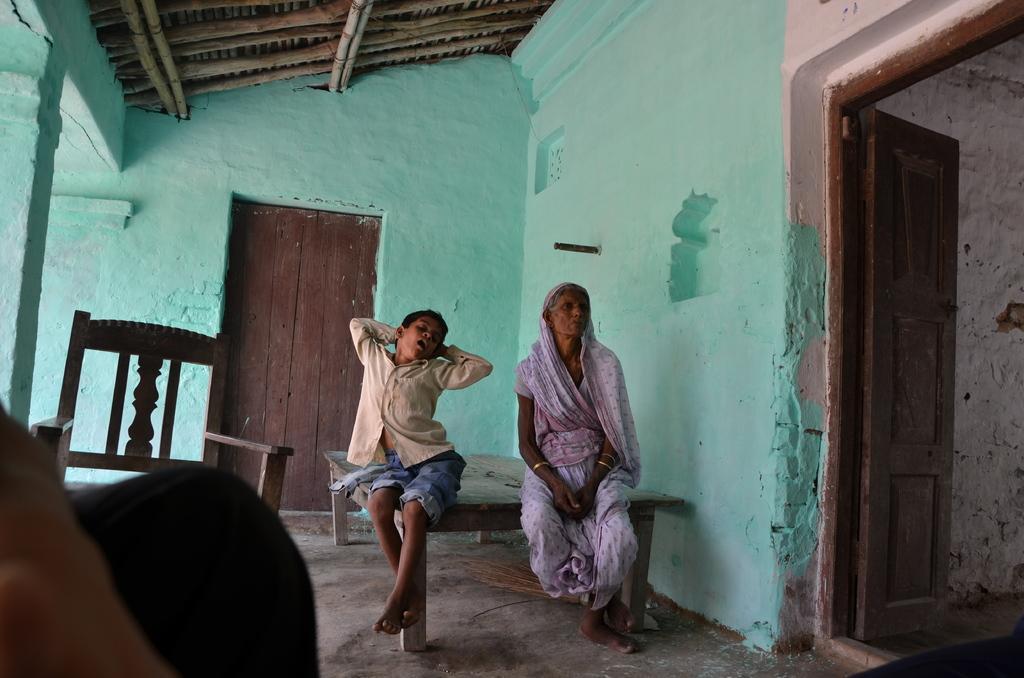Could you give a brief overview of what you see in this image? In this picture I can see two persons sitting on a wooden cot in the middle. On the left side there is a chair, in the background there are walls. On the right side I can see the door. 